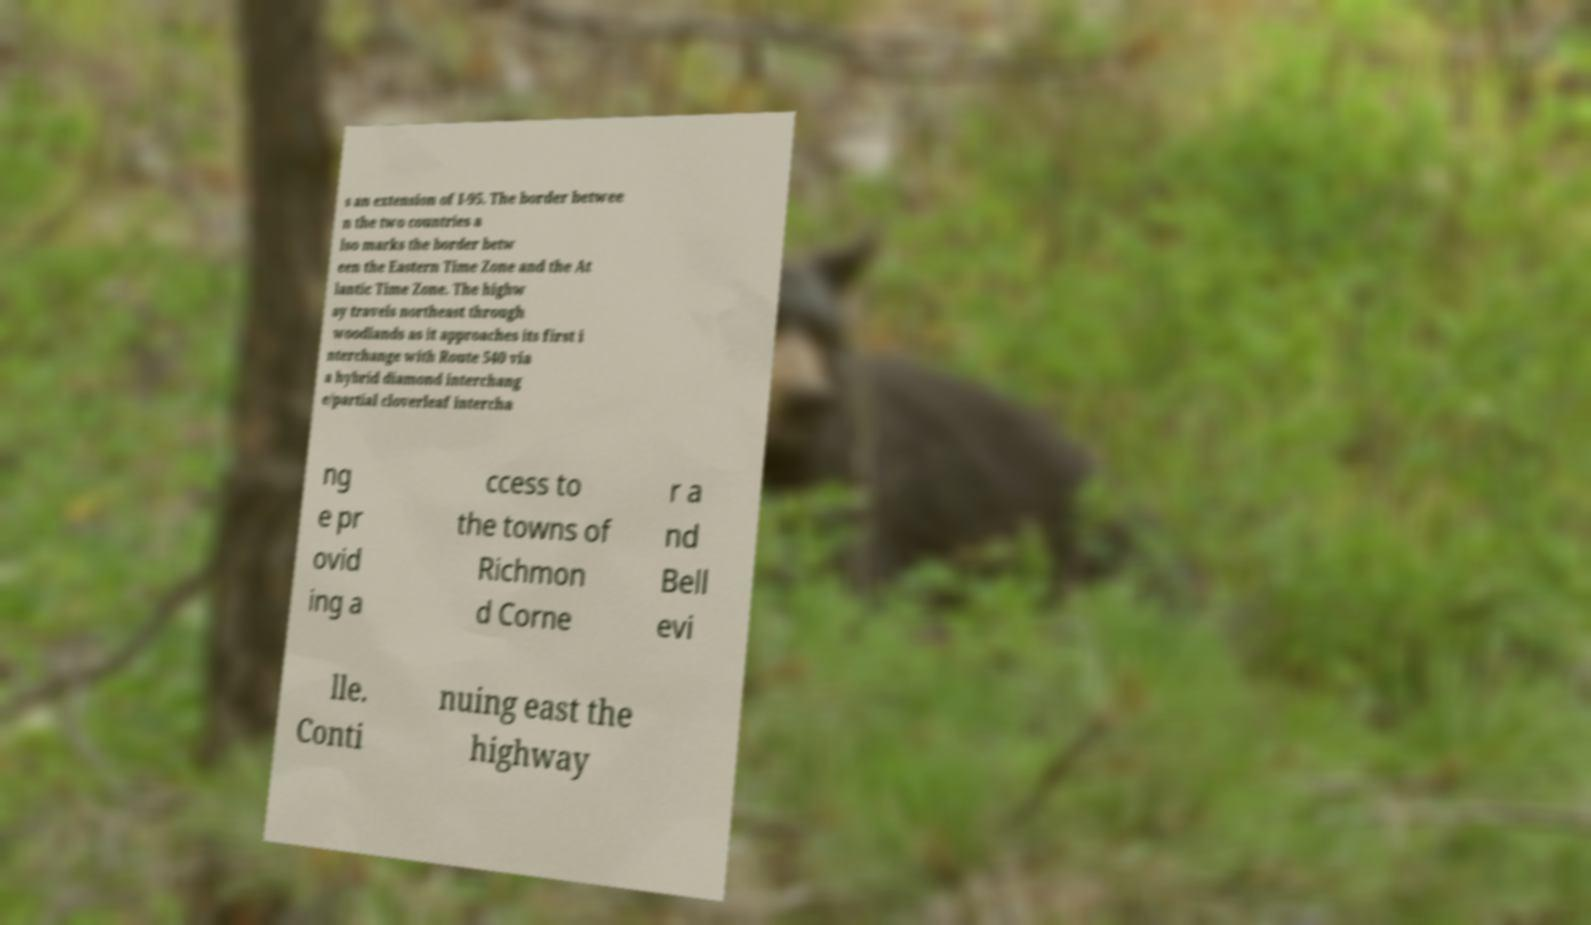Please read and relay the text visible in this image. What does it say? s an extension of I-95. The border betwee n the two countries a lso marks the border betw een the Eastern Time Zone and the At lantic Time Zone. The highw ay travels northeast through woodlands as it approaches its first i nterchange with Route 540 via a hybrid diamond interchang e/partial cloverleaf intercha ng e pr ovid ing a ccess to the towns of Richmon d Corne r a nd Bell evi lle. Conti nuing east the highway 